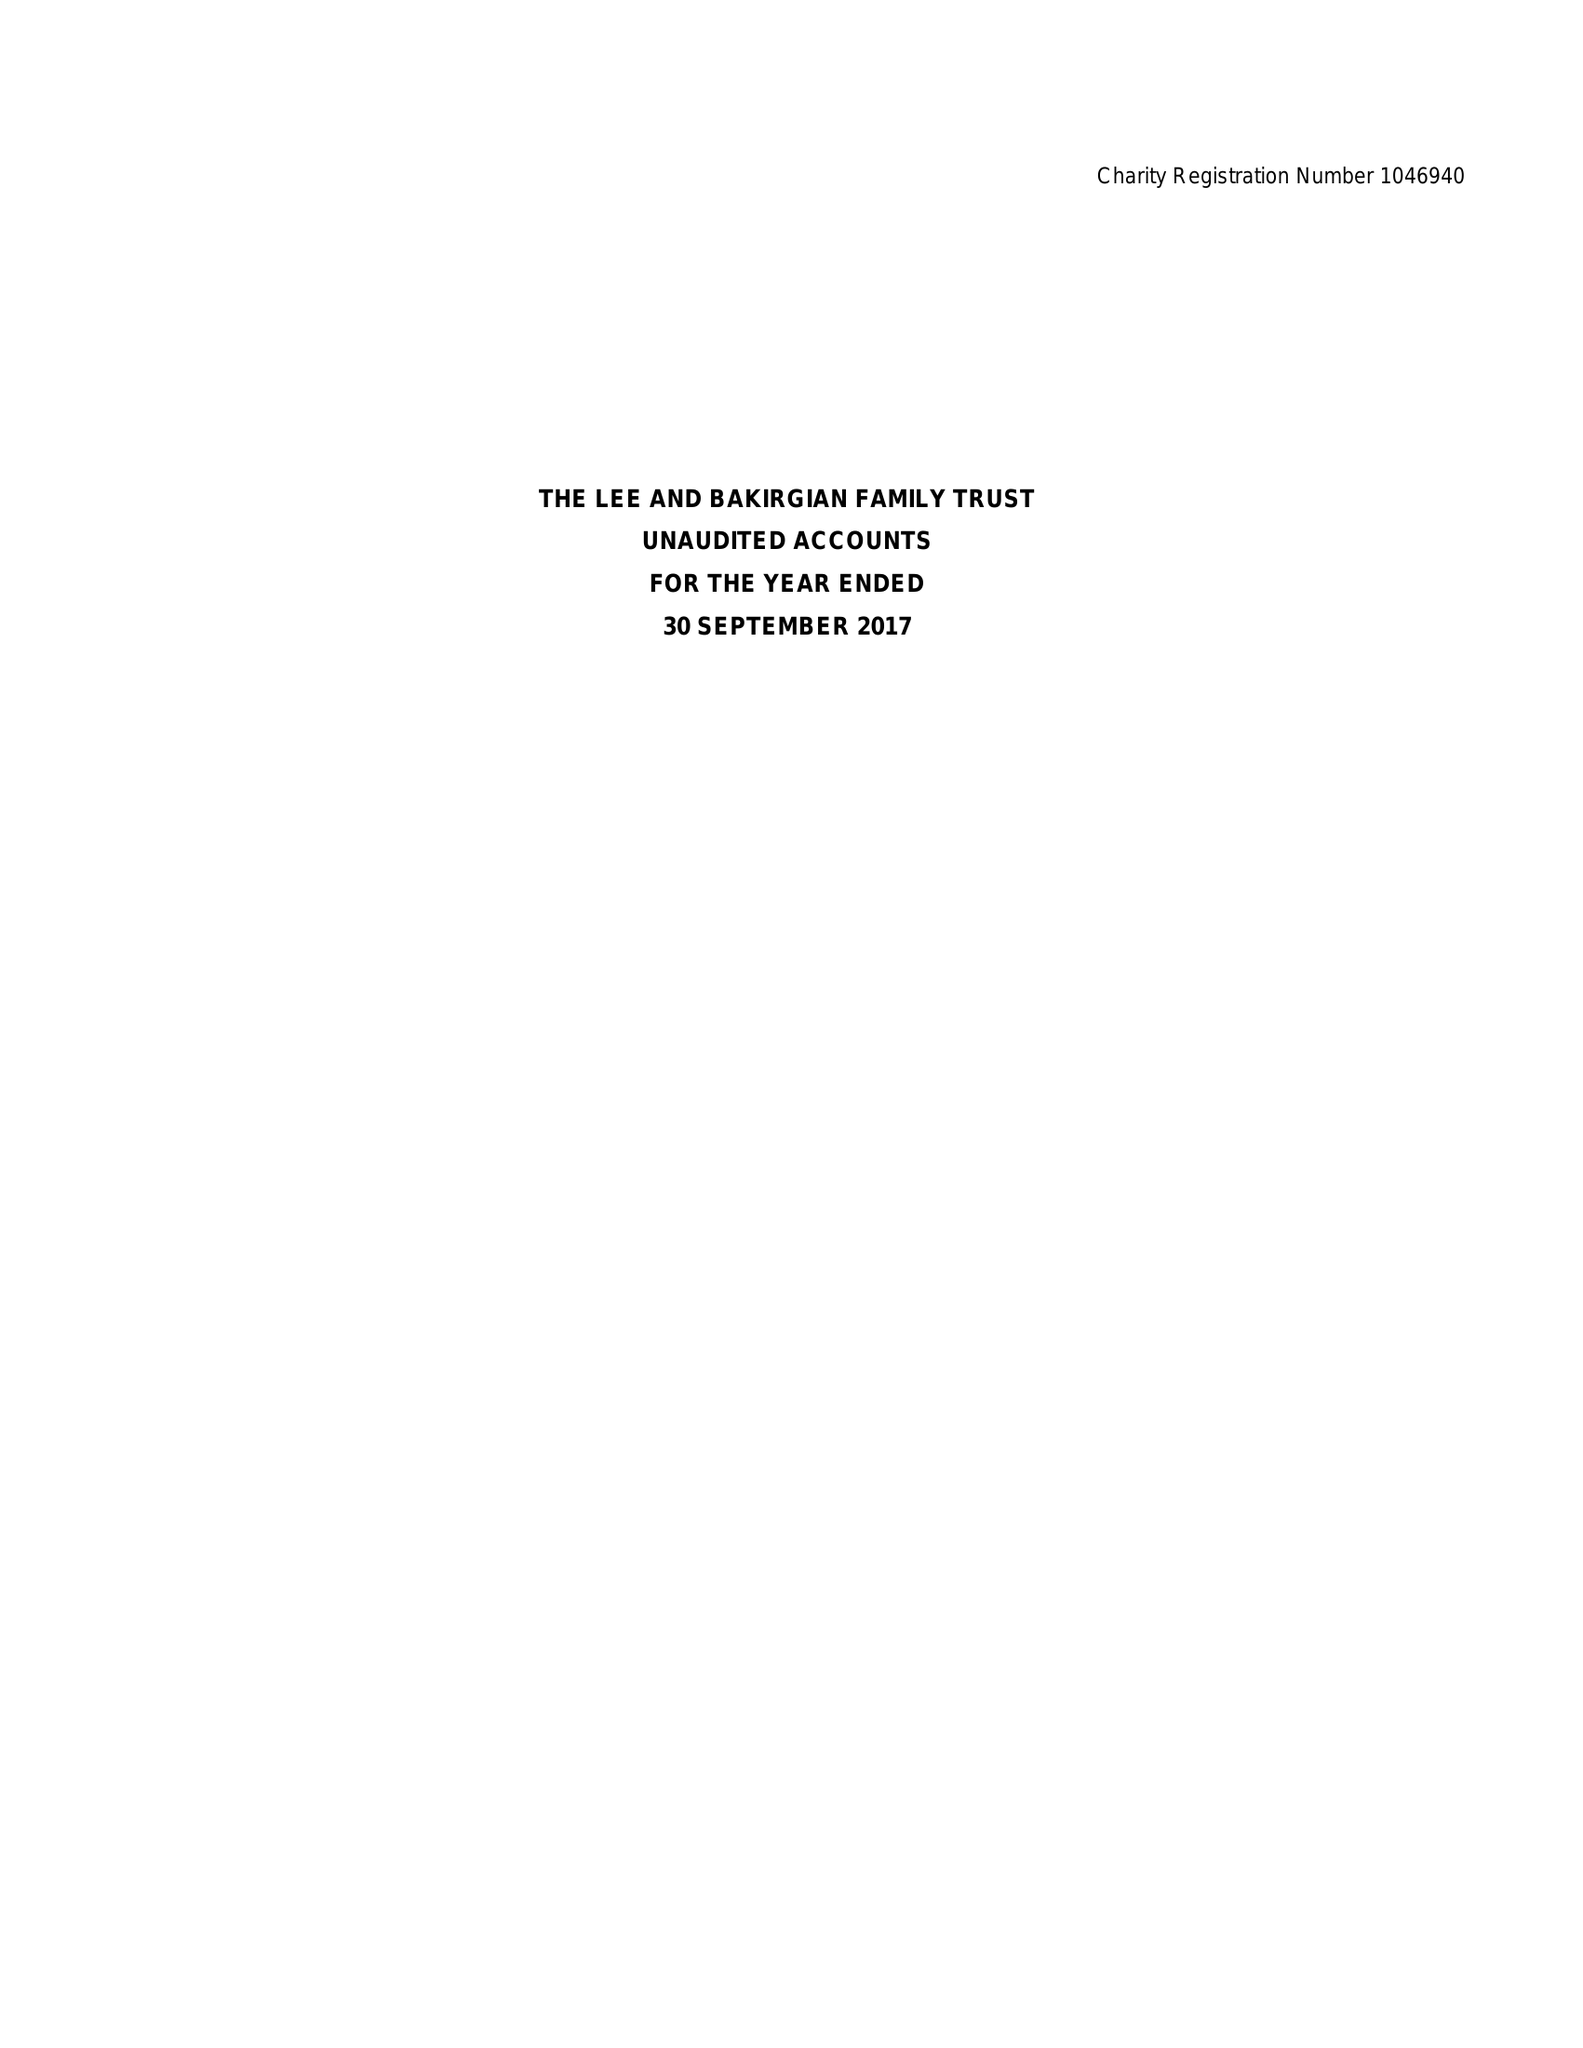What is the value for the address__street_line?
Answer the question using a single word or phrase. YEW TREE WAY 